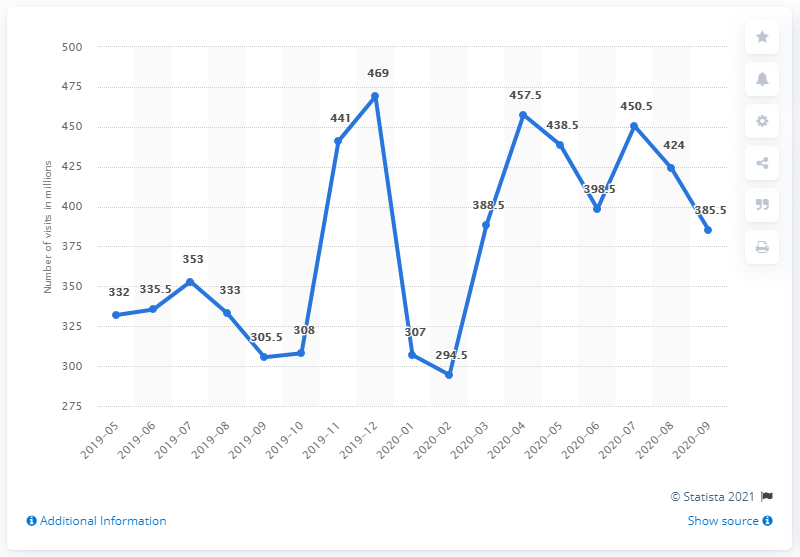Identify some key points in this picture. In February of 2020, Walmart.com had 294.5 visits. 